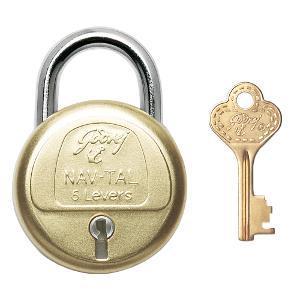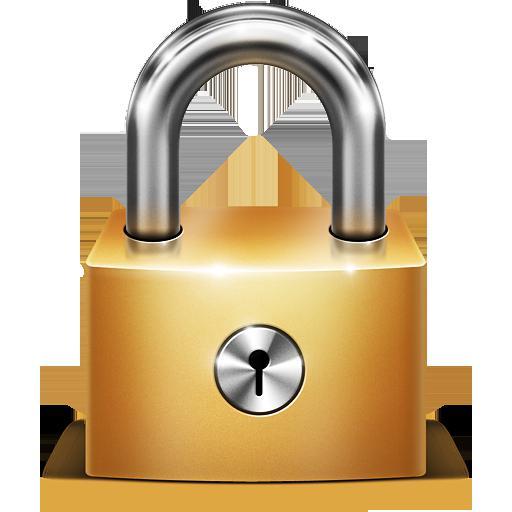The first image is the image on the left, the second image is the image on the right. Evaluate the accuracy of this statement regarding the images: "An image shows a round lock with a key next to it, but not inserted in it.". Is it true? Answer yes or no. Yes. The first image is the image on the left, the second image is the image on the right. Assess this claim about the two images: "A lock in one image is round with a front dial and optional key, while a second image shows at least one padlock with number belts that scroll.". Correct or not? Answer yes or no. No. 